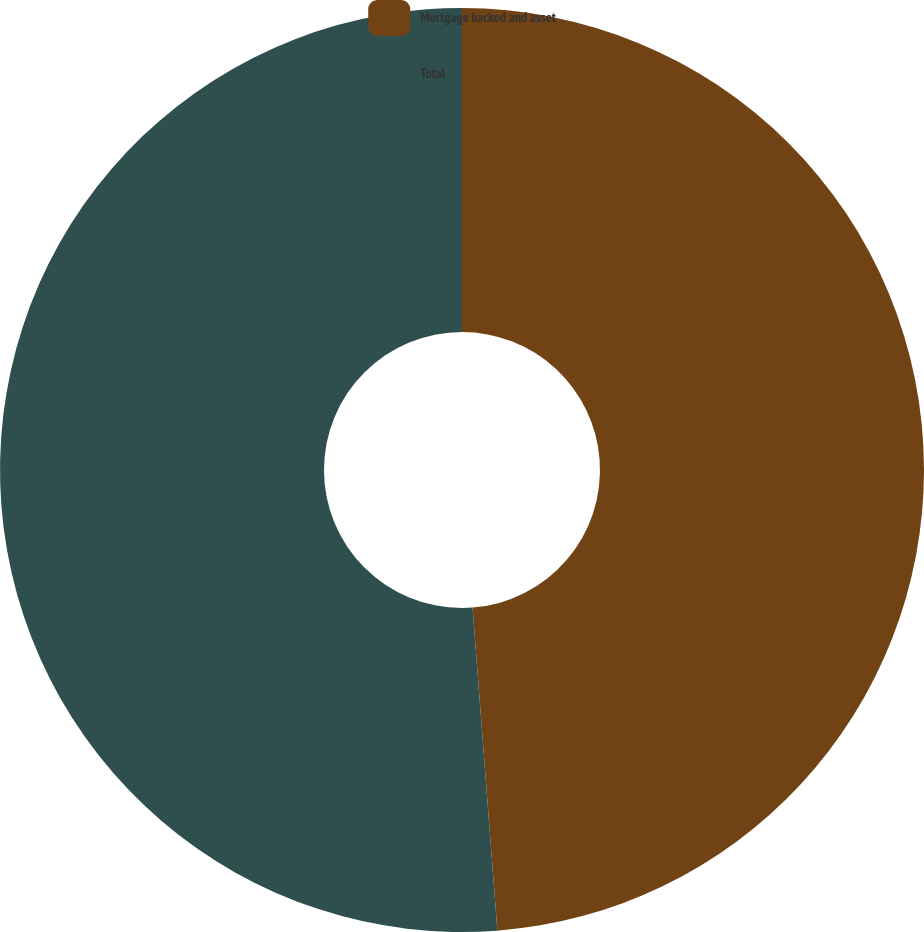<chart> <loc_0><loc_0><loc_500><loc_500><pie_chart><fcel>Mortgage backed and asset<fcel>Total<nl><fcel>48.78%<fcel>51.22%<nl></chart> 